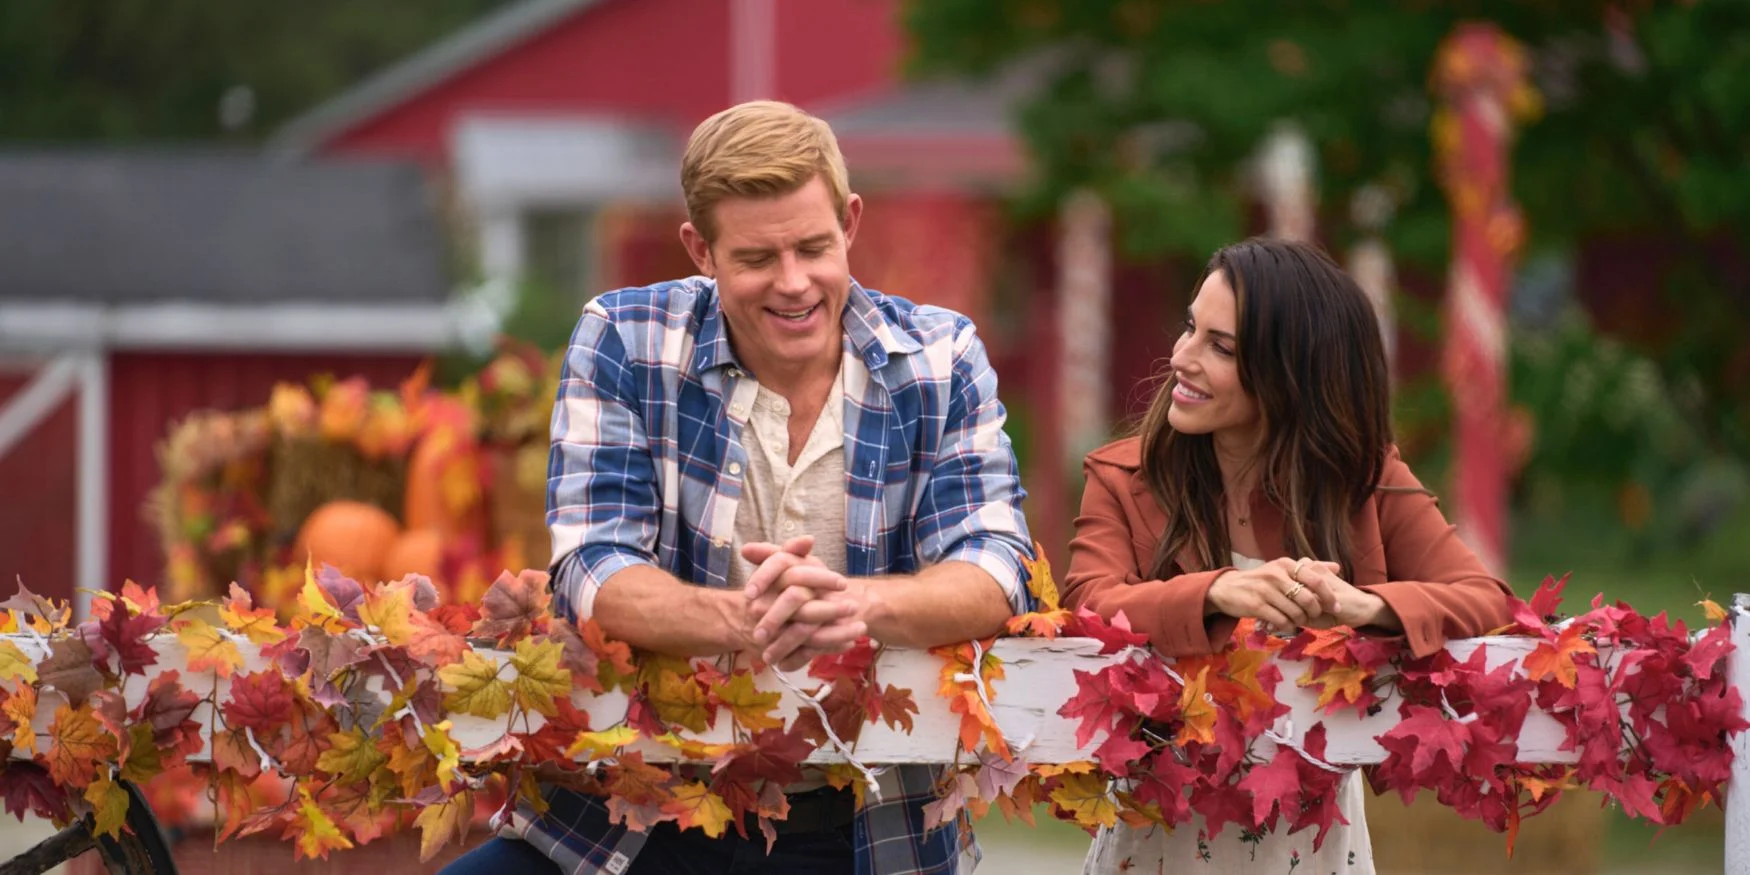Provide a brief caption that encapsulates the atmosphere of this image. A serene autumn day, where friendly conversations blossom amidst vibrant fall leaves and rustic charm. 